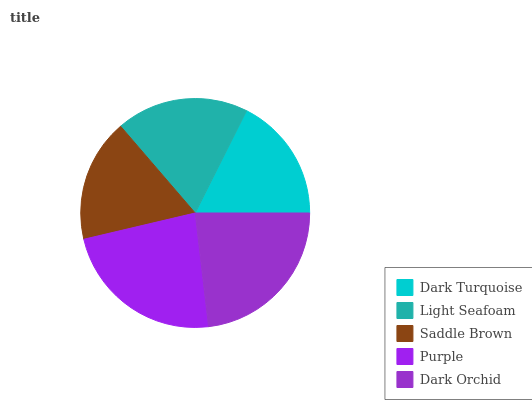Is Saddle Brown the minimum?
Answer yes or no. Yes. Is Purple the maximum?
Answer yes or no. Yes. Is Light Seafoam the minimum?
Answer yes or no. No. Is Light Seafoam the maximum?
Answer yes or no. No. Is Light Seafoam greater than Dark Turquoise?
Answer yes or no. Yes. Is Dark Turquoise less than Light Seafoam?
Answer yes or no. Yes. Is Dark Turquoise greater than Light Seafoam?
Answer yes or no. No. Is Light Seafoam less than Dark Turquoise?
Answer yes or no. No. Is Light Seafoam the high median?
Answer yes or no. Yes. Is Light Seafoam the low median?
Answer yes or no. Yes. Is Dark Turquoise the high median?
Answer yes or no. No. Is Dark Orchid the low median?
Answer yes or no. No. 